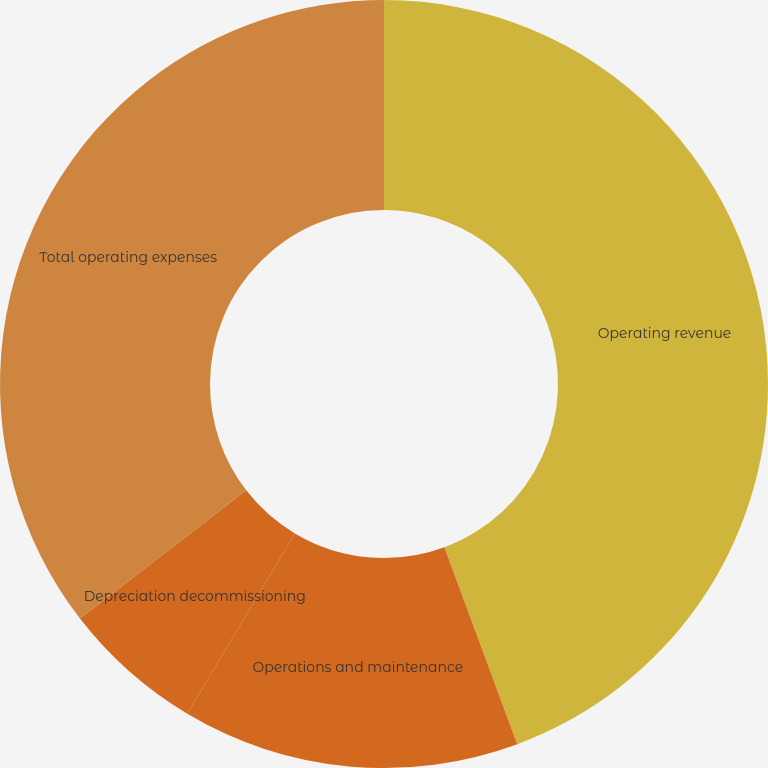<chart> <loc_0><loc_0><loc_500><loc_500><pie_chart><fcel>Operating revenue<fcel>Operations and maintenance<fcel>Depreciation decommissioning<fcel>Total operating expenses<nl><fcel>44.36%<fcel>14.2%<fcel>5.98%<fcel>35.46%<nl></chart> 